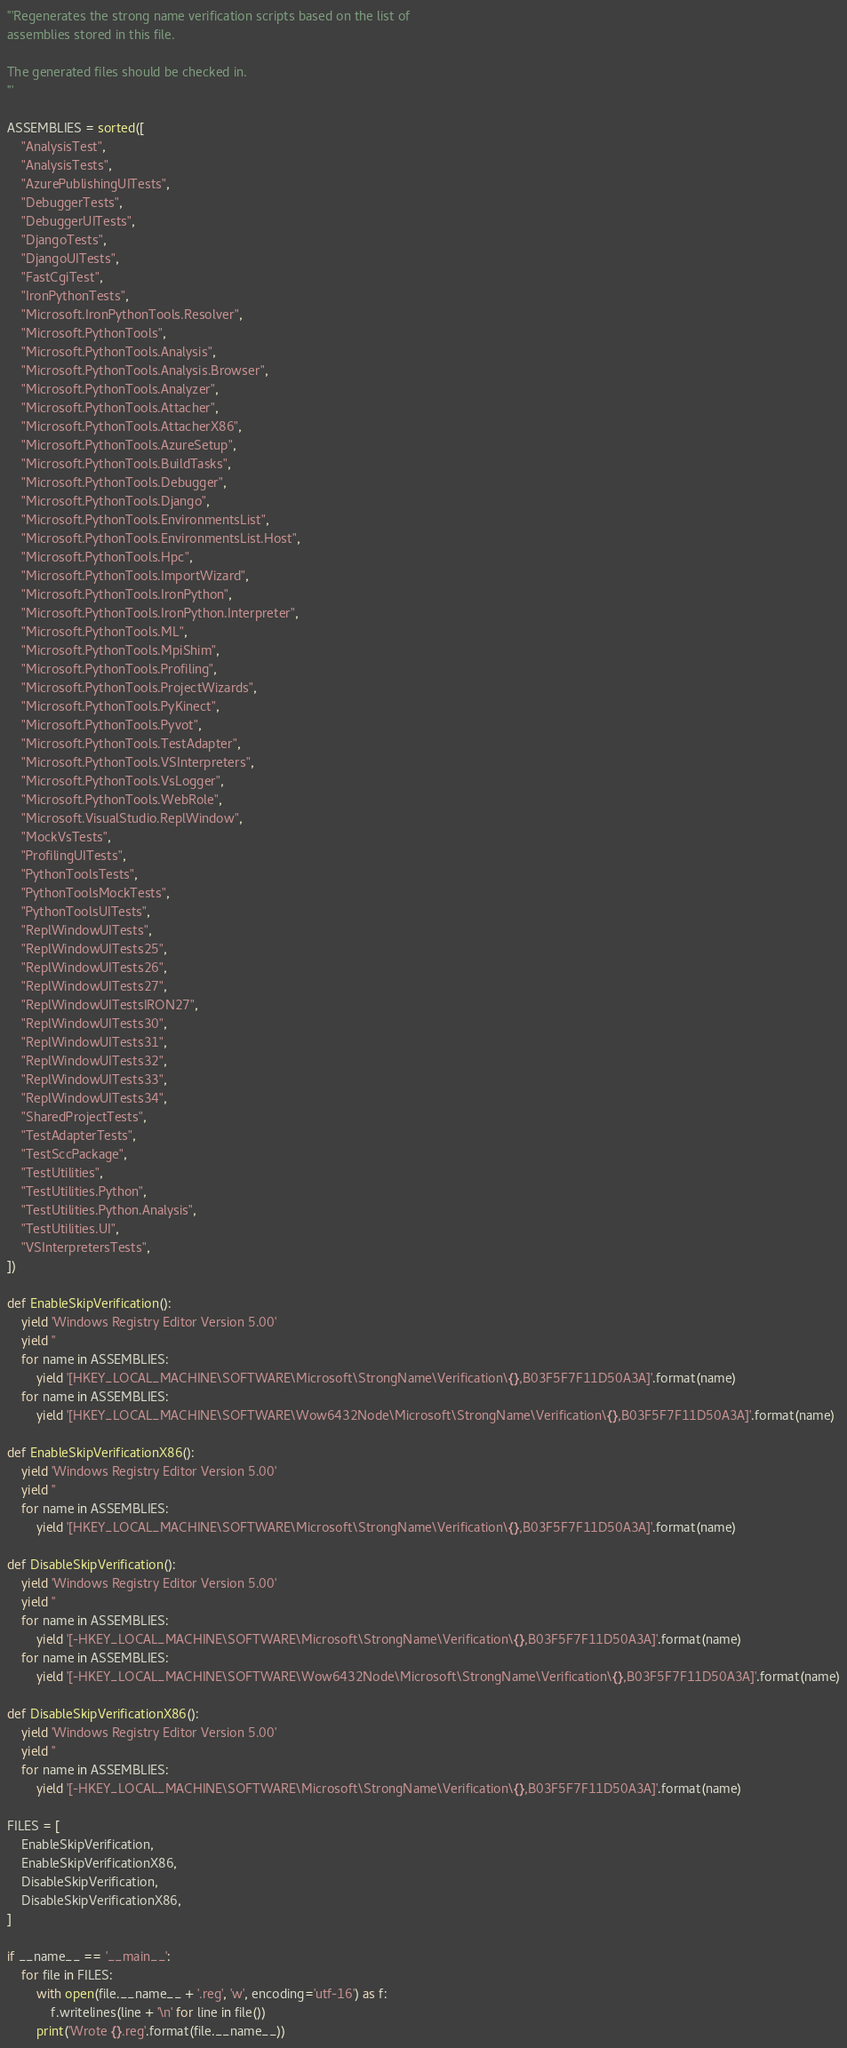<code> <loc_0><loc_0><loc_500><loc_500><_Python_>'''Regenerates the strong name verification scripts based on the list of
assemblies stored in this file.

The generated files should be checked in.
'''

ASSEMBLIES = sorted([
    "AnalysisTest",
    "AnalysisTests",
    "AzurePublishingUITests",
    "DebuggerTests",
    "DebuggerUITests",
    "DjangoTests",
    "DjangoUITests",
    "FastCgiTest",
    "IronPythonTests",
    "Microsoft.IronPythonTools.Resolver",
    "Microsoft.PythonTools",
    "Microsoft.PythonTools.Analysis",
    "Microsoft.PythonTools.Analysis.Browser",
    "Microsoft.PythonTools.Analyzer",
    "Microsoft.PythonTools.Attacher",
    "Microsoft.PythonTools.AttacherX86",
    "Microsoft.PythonTools.AzureSetup",
    "Microsoft.PythonTools.BuildTasks",
    "Microsoft.PythonTools.Debugger",
    "Microsoft.PythonTools.Django",
    "Microsoft.PythonTools.EnvironmentsList",
    "Microsoft.PythonTools.EnvironmentsList.Host",
    "Microsoft.PythonTools.Hpc",
    "Microsoft.PythonTools.ImportWizard",
    "Microsoft.PythonTools.IronPython",
    "Microsoft.PythonTools.IronPython.Interpreter",
    "Microsoft.PythonTools.ML",
    "Microsoft.PythonTools.MpiShim",
    "Microsoft.PythonTools.Profiling",
    "Microsoft.PythonTools.ProjectWizards",
    "Microsoft.PythonTools.PyKinect",
    "Microsoft.PythonTools.Pyvot",
    "Microsoft.PythonTools.TestAdapter",
    "Microsoft.PythonTools.VSInterpreters",
    "Microsoft.PythonTools.VsLogger",
    "Microsoft.PythonTools.WebRole",
    "Microsoft.VisualStudio.ReplWindow",
    "MockVsTests",
    "ProfilingUITests",
    "PythonToolsTests",
    "PythonToolsMockTests",
    "PythonToolsUITests",
    "ReplWindowUITests",
    "ReplWindowUITests25",
    "ReplWindowUITests26",
    "ReplWindowUITests27",
    "ReplWindowUITestsIRON27",
    "ReplWindowUITests30",
    "ReplWindowUITests31",
    "ReplWindowUITests32",
    "ReplWindowUITests33",
    "ReplWindowUITests34",
    "SharedProjectTests",
    "TestAdapterTests",
    "TestSccPackage",
    "TestUtilities",
    "TestUtilities.Python",
    "TestUtilities.Python.Analysis",
    "TestUtilities.UI",
    "VSInterpretersTests",
])

def EnableSkipVerification():
    yield 'Windows Registry Editor Version 5.00'
    yield ''
    for name in ASSEMBLIES:
        yield '[HKEY_LOCAL_MACHINE\SOFTWARE\Microsoft\StrongName\Verification\{},B03F5F7F11D50A3A]'.format(name)
    for name in ASSEMBLIES:
        yield '[HKEY_LOCAL_MACHINE\SOFTWARE\Wow6432Node\Microsoft\StrongName\Verification\{},B03F5F7F11D50A3A]'.format(name)

def EnableSkipVerificationX86():
    yield 'Windows Registry Editor Version 5.00'
    yield ''
    for name in ASSEMBLIES:
        yield '[HKEY_LOCAL_MACHINE\SOFTWARE\Microsoft\StrongName\Verification\{},B03F5F7F11D50A3A]'.format(name)

def DisableSkipVerification():
    yield 'Windows Registry Editor Version 5.00'
    yield ''
    for name in ASSEMBLIES:
        yield '[-HKEY_LOCAL_MACHINE\SOFTWARE\Microsoft\StrongName\Verification\{},B03F5F7F11D50A3A]'.format(name)
    for name in ASSEMBLIES:
        yield '[-HKEY_LOCAL_MACHINE\SOFTWARE\Wow6432Node\Microsoft\StrongName\Verification\{},B03F5F7F11D50A3A]'.format(name)

def DisableSkipVerificationX86():
    yield 'Windows Registry Editor Version 5.00'
    yield ''
    for name in ASSEMBLIES:
        yield '[-HKEY_LOCAL_MACHINE\SOFTWARE\Microsoft\StrongName\Verification\{},B03F5F7F11D50A3A]'.format(name)

FILES = [
    EnableSkipVerification,
    EnableSkipVerificationX86,
    DisableSkipVerification,
    DisableSkipVerificationX86,
]

if __name__ == '__main__':
    for file in FILES:
        with open(file.__name__ + '.reg', 'w', encoding='utf-16') as f:
            f.writelines(line + '\n' for line in file())
        print('Wrote {}.reg'.format(file.__name__))
</code> 